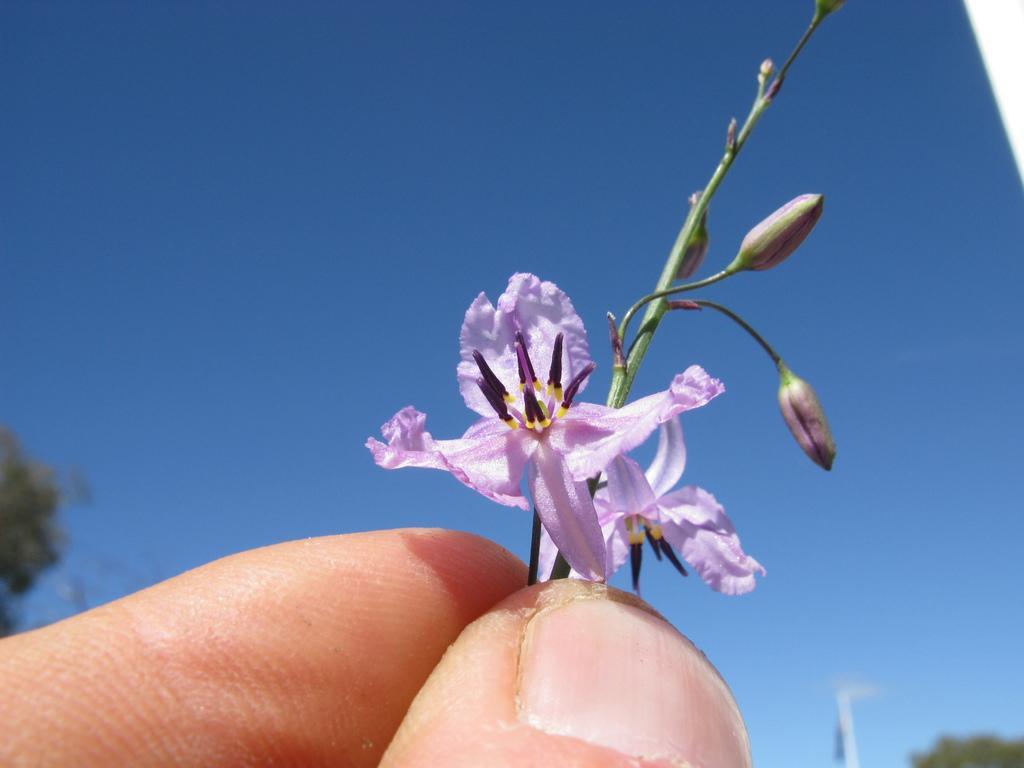Describe this image in one or two sentences. In this image, we can see fingers of a person holding flowers and stem with flower buds. In the background, there is the sky and trees. 